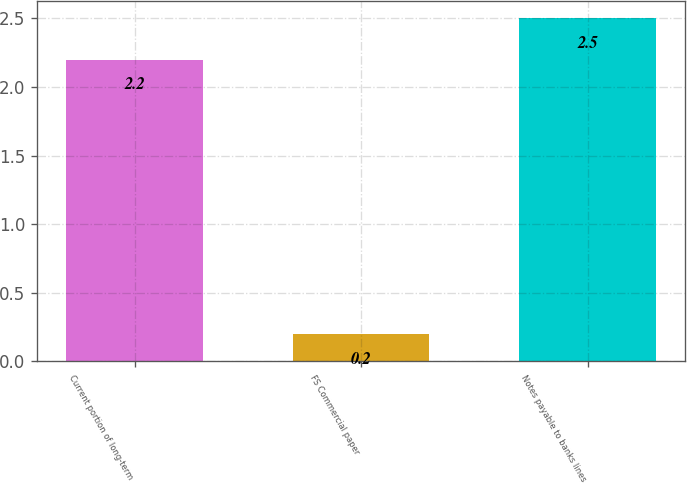Convert chart to OTSL. <chart><loc_0><loc_0><loc_500><loc_500><bar_chart><fcel>Current portion of long-term<fcel>FS Commercial paper<fcel>Notes payable to banks lines<nl><fcel>2.2<fcel>0.2<fcel>2.5<nl></chart> 